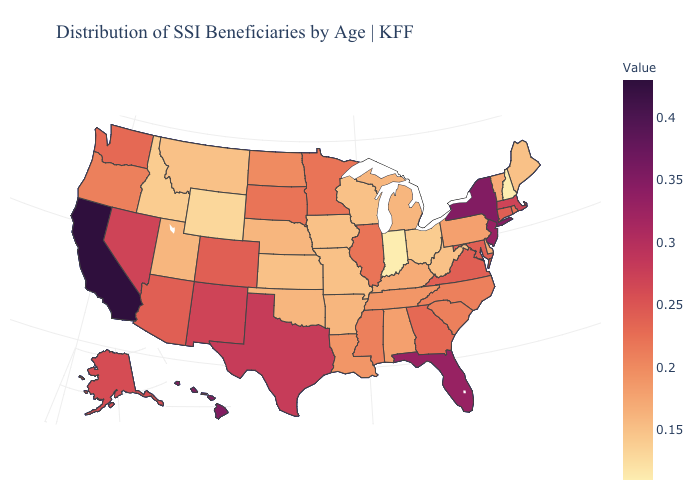Which states hav the highest value in the MidWest?
Keep it brief. Illinois, Minnesota, South Dakota. Is the legend a continuous bar?
Concise answer only. Yes. Does Colorado have the highest value in the USA?
Quick response, please. No. Which states hav the highest value in the MidWest?
Give a very brief answer. Illinois, Minnesota, South Dakota. Does South Carolina have a lower value than Massachusetts?
Keep it brief. Yes. 